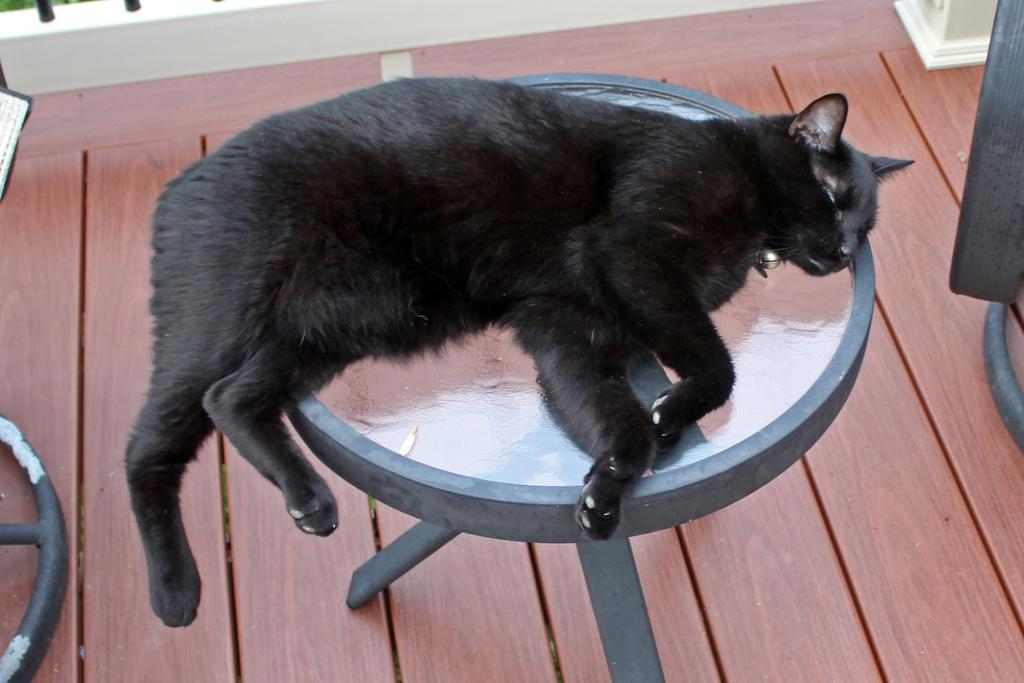What type of animal is in the image? There is a black cat in the image. What is the cat doing in the image? The cat is sleeping on a table. What can be seen at the top of the image? There is a railing visible at the top of the image. How many bikes are parked on the bridge in the image? There are no bikes or bridges present in the image. 